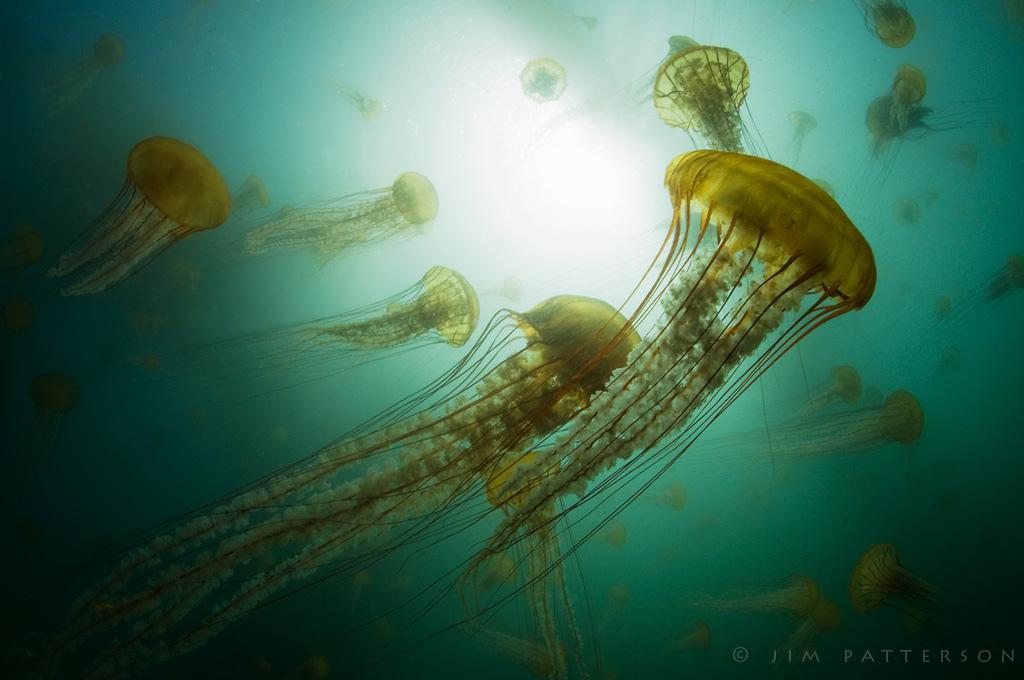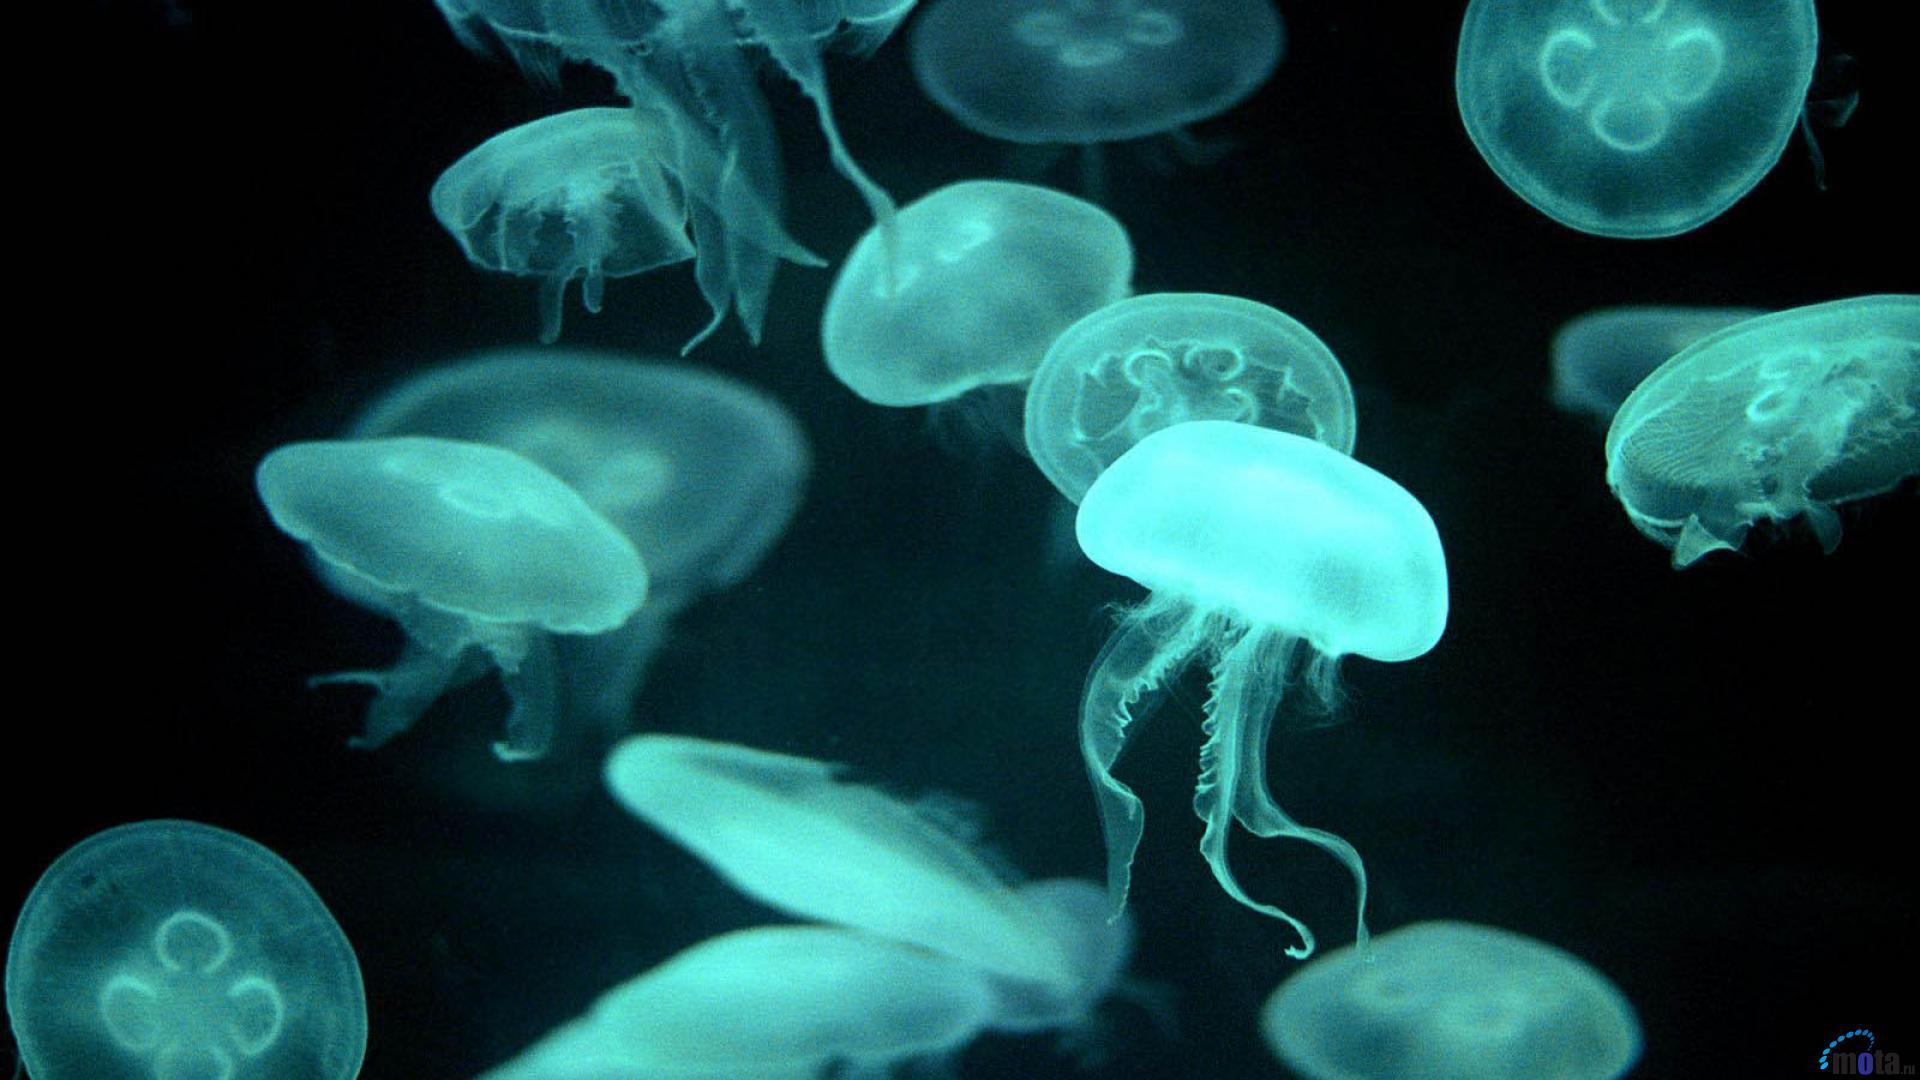The first image is the image on the left, the second image is the image on the right. Analyze the images presented: Is the assertion "A woman in a swimsuit is in the water near a jellyfish in the right image, and the left image features one jellyfish with tentacles trailing horizontally." valid? Answer yes or no. No. The first image is the image on the left, the second image is the image on the right. For the images shown, is this caption "A woman in a swimsuit swims in the water near at least one jellyfish in the image on the right." true? Answer yes or no. No. 